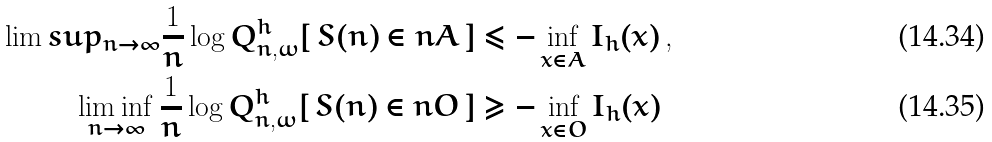<formula> <loc_0><loc_0><loc_500><loc_500>\lim s u p _ { n \to \infty } \frac { 1 } { n } \log Q ^ { h } _ { n , \omega } [ \, S ( n ) \in n A \, ] & \leq - \inf _ { x \in A } I _ { h } ( x ) \, , \\ \liminf _ { n \to \infty } \frac { 1 } { n } \log Q ^ { h } _ { n , \omega } [ \, S ( n ) \in n O \, ] & \geq - \inf _ { x \in O } I _ { h } ( x )</formula> 